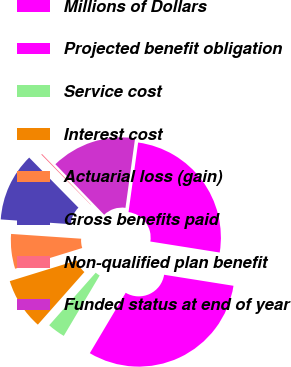Convert chart. <chart><loc_0><loc_0><loc_500><loc_500><pie_chart><fcel>Millions of Dollars<fcel>Projected benefit obligation<fcel>Service cost<fcel>Interest cost<fcel>Actuarial loss (gain)<fcel>Gross benefits paid<fcel>Non-qualified plan benefit<fcel>Funded status at end of year<nl><fcel>25.32%<fcel>31.02%<fcel>3.0%<fcel>8.7%<fcel>5.85%<fcel>11.55%<fcel>0.15%<fcel>14.4%<nl></chart> 